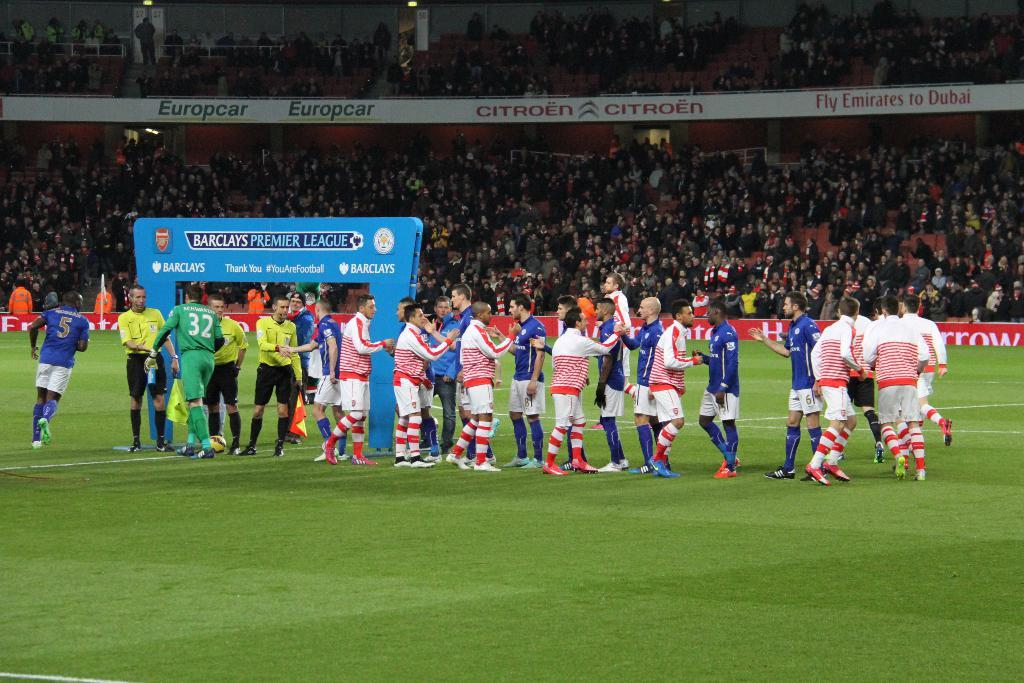<image>
Give a short and clear explanation of the subsequent image. A huge Barclays Premier League sign has the hashtag #YouAreFootball on it. 